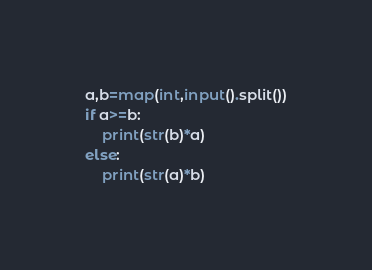<code> <loc_0><loc_0><loc_500><loc_500><_Python_>a,b=map(int,input().split())
if a>=b:
    print(str(b)*a)
else:
    print(str(a)*b)
</code> 